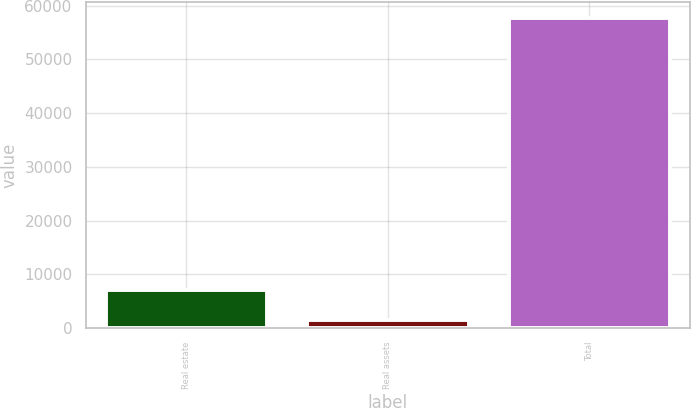<chart> <loc_0><loc_0><loc_500><loc_500><bar_chart><fcel>Real estate<fcel>Real assets<fcel>Total<nl><fcel>7134.8<fcel>1506<fcel>57794<nl></chart> 